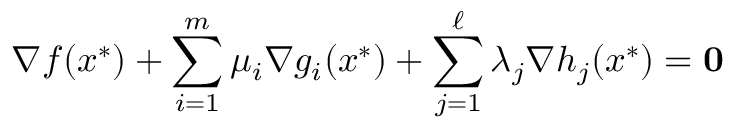Convert formula to latex. <formula><loc_0><loc_0><loc_500><loc_500>\nabla f ( x ^ { * } ) + \sum _ { i = 1 } ^ { m } \mu _ { i } \nabla g _ { i } ( x ^ { * } ) + \sum _ { j = 1 } ^ { \ell } \lambda _ { j } \nabla h _ { j } ( x ^ { * } ) = 0</formula> 